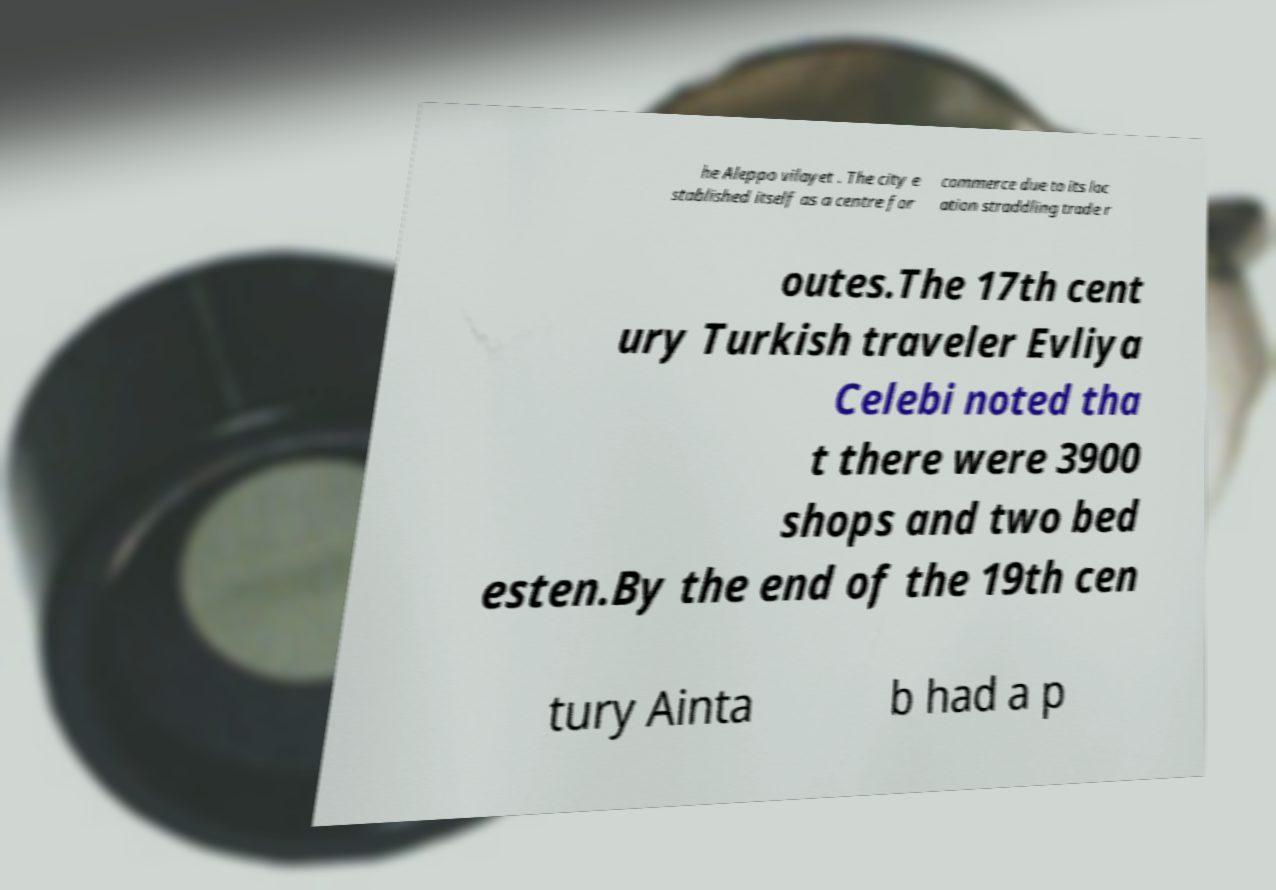For documentation purposes, I need the text within this image transcribed. Could you provide that? he Aleppo vilayet . The city e stablished itself as a centre for commerce due to its loc ation straddling trade r outes.The 17th cent ury Turkish traveler Evliya Celebi noted tha t there were 3900 shops and two bed esten.By the end of the 19th cen tury Ainta b had a p 